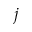<formula> <loc_0><loc_0><loc_500><loc_500>j</formula> 